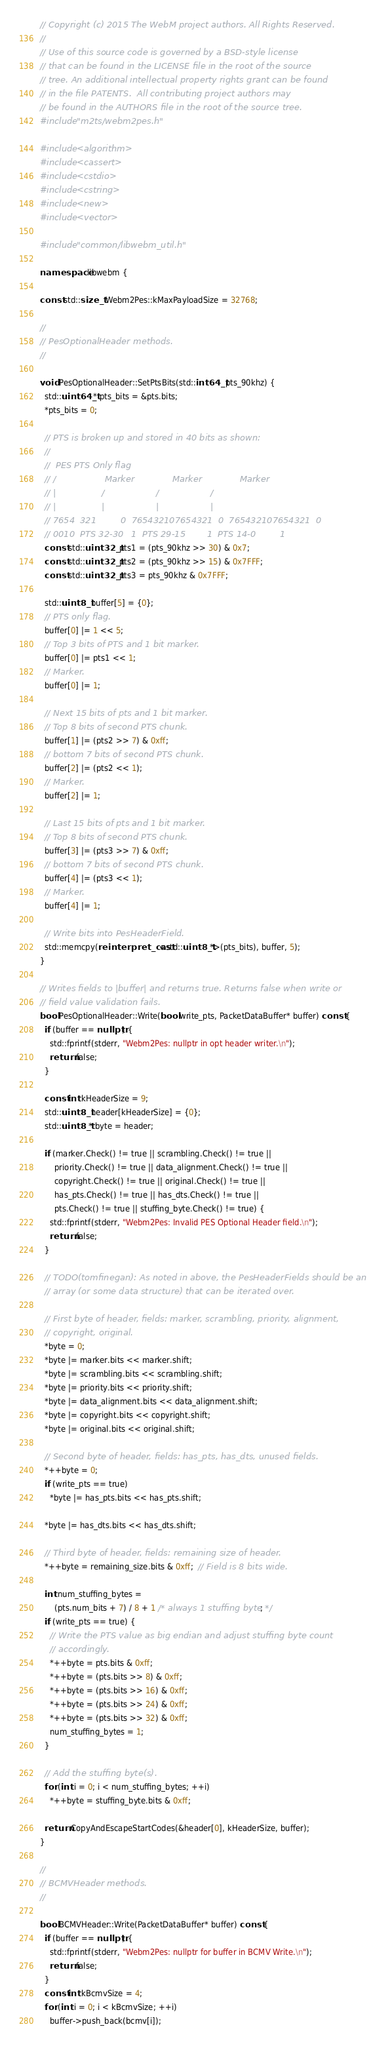<code> <loc_0><loc_0><loc_500><loc_500><_C++_>// Copyright (c) 2015 The WebM project authors. All Rights Reserved.
//
// Use of this source code is governed by a BSD-style license
// that can be found in the LICENSE file in the root of the source
// tree. An additional intellectual property rights grant can be found
// in the file PATENTS.  All contributing project authors may
// be found in the AUTHORS file in the root of the source tree.
#include "m2ts/webm2pes.h"

#include <algorithm>
#include <cassert>
#include <cstdio>
#include <cstring>
#include <new>
#include <vector>

#include "common/libwebm_util.h"

namespace libwebm {

const std::size_t Webm2Pes::kMaxPayloadSize = 32768;

//
// PesOptionalHeader methods.
//

void PesOptionalHeader::SetPtsBits(std::int64_t pts_90khz) {
  std::uint64_t* pts_bits = &pts.bits;
  *pts_bits = 0;

  // PTS is broken up and stored in 40 bits as shown:
  //
  //  PES PTS Only flag
  // /                  Marker              Marker              Marker
  // |                 /                   /                   /
  // |                 |                   |                   |
  // 7654  321         0  765432107654321  0  765432107654321  0
  // 0010  PTS 32-30   1  PTS 29-15        1  PTS 14-0         1
  const std::uint32_t pts1 = (pts_90khz >> 30) & 0x7;
  const std::uint32_t pts2 = (pts_90khz >> 15) & 0x7FFF;
  const std::uint32_t pts3 = pts_90khz & 0x7FFF;

  std::uint8_t buffer[5] = {0};
  // PTS only flag.
  buffer[0] |= 1 << 5;
  // Top 3 bits of PTS and 1 bit marker.
  buffer[0] |= pts1 << 1;
  // Marker.
  buffer[0] |= 1;

  // Next 15 bits of pts and 1 bit marker.
  // Top 8 bits of second PTS chunk.
  buffer[1] |= (pts2 >> 7) & 0xff;
  // bottom 7 bits of second PTS chunk.
  buffer[2] |= (pts2 << 1);
  // Marker.
  buffer[2] |= 1;

  // Last 15 bits of pts and 1 bit marker.
  // Top 8 bits of second PTS chunk.
  buffer[3] |= (pts3 >> 7) & 0xff;
  // bottom 7 bits of second PTS chunk.
  buffer[4] |= (pts3 << 1);
  // Marker.
  buffer[4] |= 1;

  // Write bits into PesHeaderField.
  std::memcpy(reinterpret_cast<std::uint8_t*>(pts_bits), buffer, 5);
}

// Writes fields to |buffer| and returns true. Returns false when write or
// field value validation fails.
bool PesOptionalHeader::Write(bool write_pts, PacketDataBuffer* buffer) const {
  if (buffer == nullptr) {
    std::fprintf(stderr, "Webm2Pes: nullptr in opt header writer.\n");
    return false;
  }

  const int kHeaderSize = 9;
  std::uint8_t header[kHeaderSize] = {0};
  std::uint8_t* byte = header;

  if (marker.Check() != true || scrambling.Check() != true ||
      priority.Check() != true || data_alignment.Check() != true ||
      copyright.Check() != true || original.Check() != true ||
      has_pts.Check() != true || has_dts.Check() != true ||
      pts.Check() != true || stuffing_byte.Check() != true) {
    std::fprintf(stderr, "Webm2Pes: Invalid PES Optional Header field.\n");
    return false;
  }

  // TODO(tomfinegan): As noted in above, the PesHeaderFields should be an
  // array (or some data structure) that can be iterated over.

  // First byte of header, fields: marker, scrambling, priority, alignment,
  // copyright, original.
  *byte = 0;
  *byte |= marker.bits << marker.shift;
  *byte |= scrambling.bits << scrambling.shift;
  *byte |= priority.bits << priority.shift;
  *byte |= data_alignment.bits << data_alignment.shift;
  *byte |= copyright.bits << copyright.shift;
  *byte |= original.bits << original.shift;

  // Second byte of header, fields: has_pts, has_dts, unused fields.
  *++byte = 0;
  if (write_pts == true)
    *byte |= has_pts.bits << has_pts.shift;

  *byte |= has_dts.bits << has_dts.shift;

  // Third byte of header, fields: remaining size of header.
  *++byte = remaining_size.bits & 0xff;  // Field is 8 bits wide.

  int num_stuffing_bytes =
      (pts.num_bits + 7) / 8 + 1 /* always 1 stuffing byte */;
  if (write_pts == true) {
    // Write the PTS value as big endian and adjust stuffing byte count
    // accordingly.
    *++byte = pts.bits & 0xff;
    *++byte = (pts.bits >> 8) & 0xff;
    *++byte = (pts.bits >> 16) & 0xff;
    *++byte = (pts.bits >> 24) & 0xff;
    *++byte = (pts.bits >> 32) & 0xff;
    num_stuffing_bytes = 1;
  }

  // Add the stuffing byte(s).
  for (int i = 0; i < num_stuffing_bytes; ++i)
    *++byte = stuffing_byte.bits & 0xff;

  return CopyAndEscapeStartCodes(&header[0], kHeaderSize, buffer);
}

//
// BCMVHeader methods.
//

bool BCMVHeader::Write(PacketDataBuffer* buffer) const {
  if (buffer == nullptr) {
    std::fprintf(stderr, "Webm2Pes: nullptr for buffer in BCMV Write.\n");
    return false;
  }
  const int kBcmvSize = 4;
  for (int i = 0; i < kBcmvSize; ++i)
    buffer->push_back(bcmv[i]);
</code> 